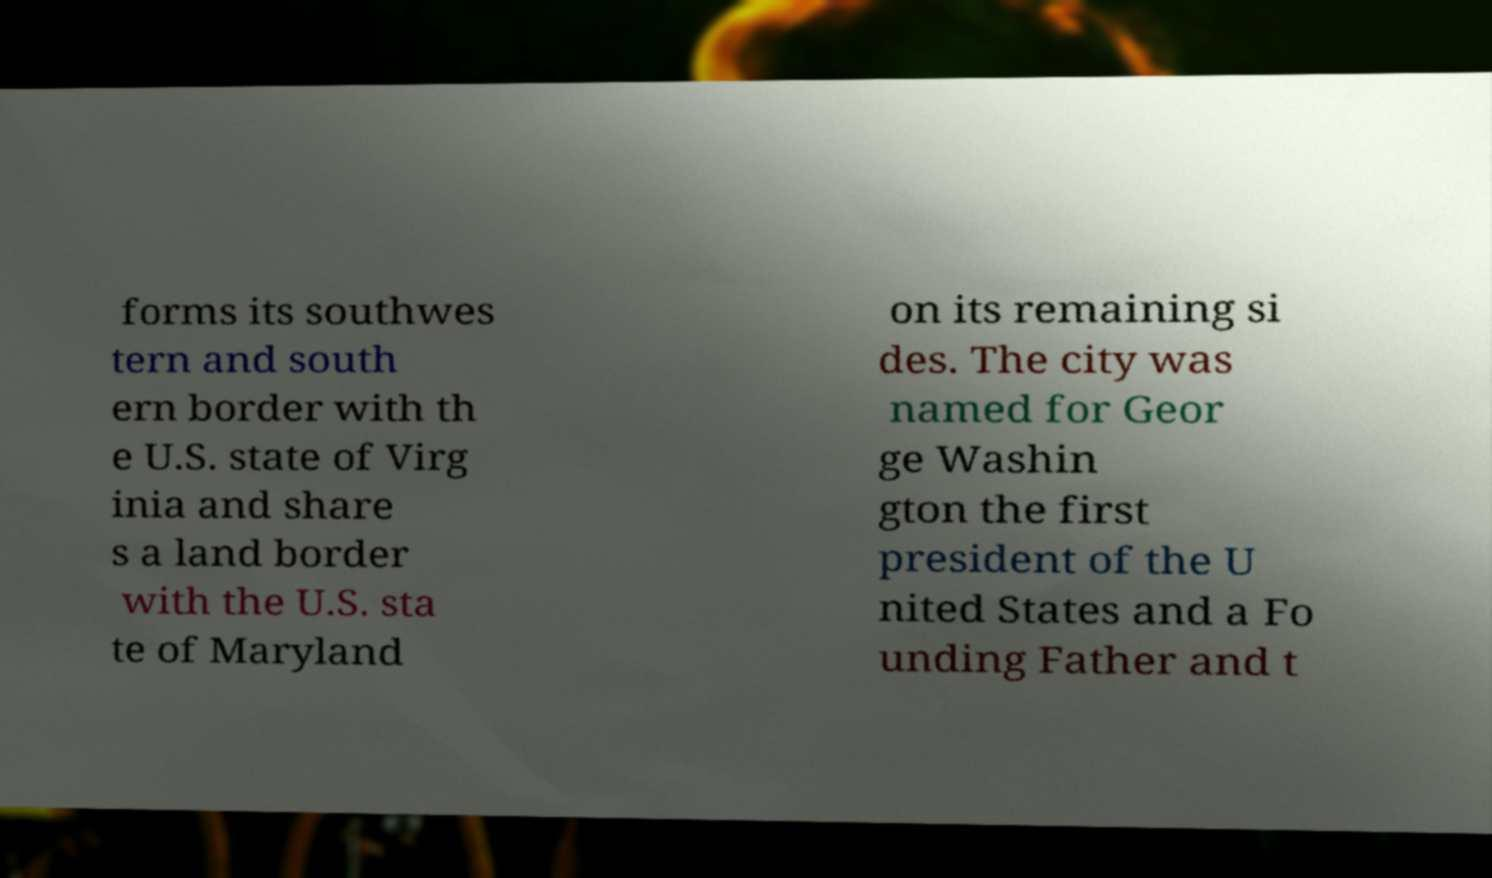Can you accurately transcribe the text from the provided image for me? forms its southwes tern and south ern border with th e U.S. state of Virg inia and share s a land border with the U.S. sta te of Maryland on its remaining si des. The city was named for Geor ge Washin gton the first president of the U nited States and a Fo unding Father and t 